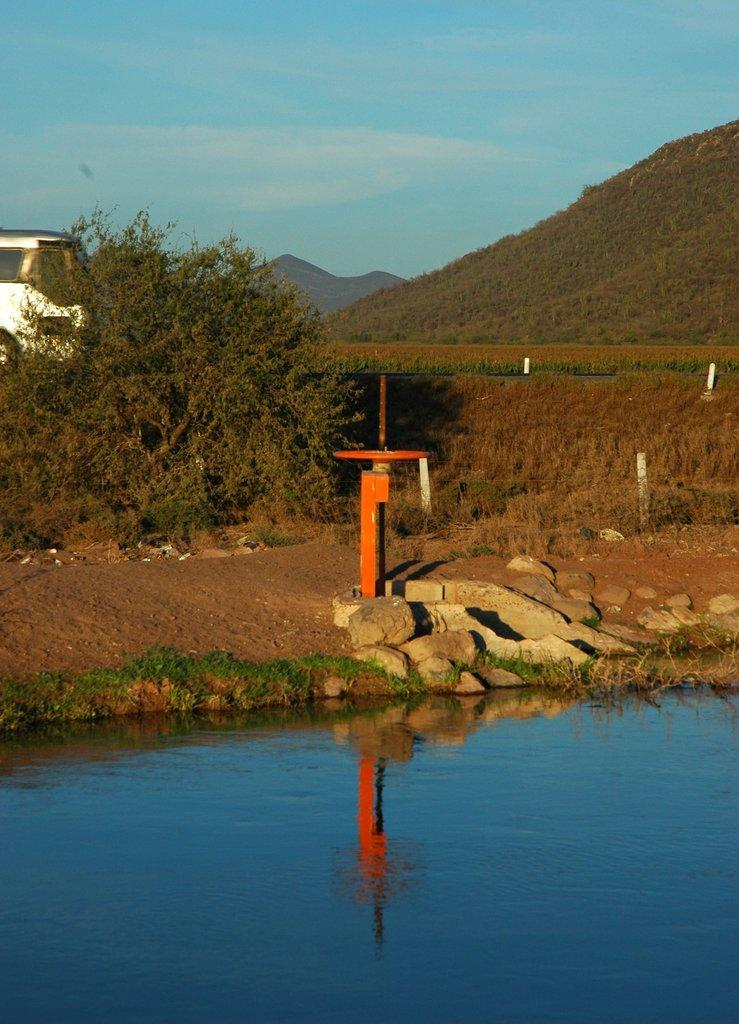What is present at the bottom of the image? There is water at the bottom of the image. What can be seen on the left side of the image? There is a tree on the left side of the image. What is visible at the top of the image? The sky is visible at the top of the image. What type of advertisement can be seen on the tree in the image? There is no advertisement present on the tree in the image. How does the size of the tree compare to the size of the water in the image? The size of the tree and the water cannot be compared in the image, as their sizes are not explicitly stated. 